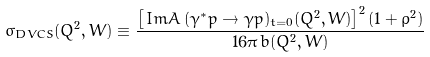<formula> <loc_0><loc_0><loc_500><loc_500>\sigma _ { D V C S } ( Q ^ { 2 } , W ) \equiv \frac { \left [ \, I m { A } \, ( \gamma ^ { * } p \to \gamma p ) _ { t = 0 } ( Q ^ { 2 } , W ) \right ] ^ { 2 } ( 1 + \rho ^ { 2 } ) } { 1 6 \pi \, b ( Q ^ { 2 } , W ) }</formula> 